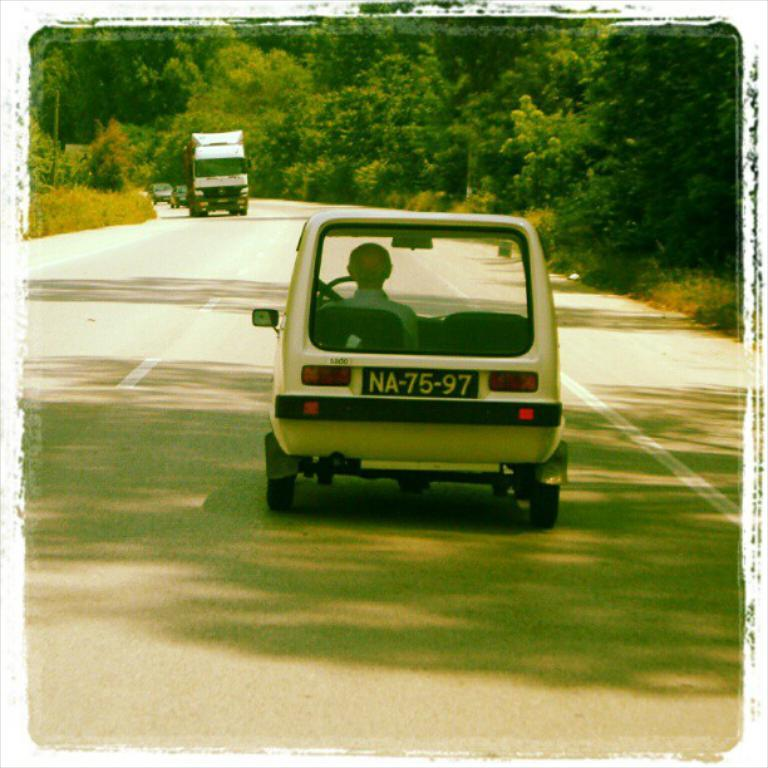What type of vehicles are present in the image? There are cars and a truck in the image. What can be seen in the background of the image? There is grass and trees visible in the image. What type of brush is being used to paint the truck in the image? There is no brush or painting activity present in the image; it features cars, a truck, grass, and trees. 